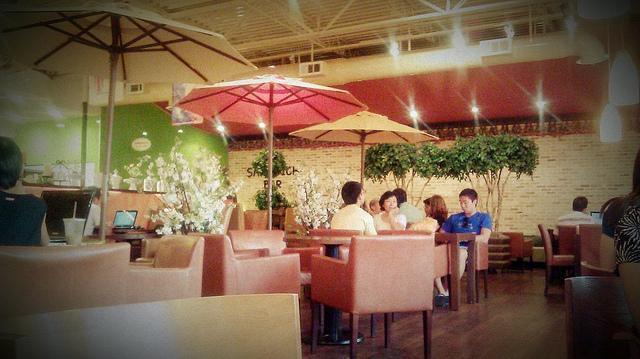What type of restaurant does this appear to be?
Indicate the correct response by choosing from the four available options to answer the question.
Options: Asian, italian, english, greek. Asian. 